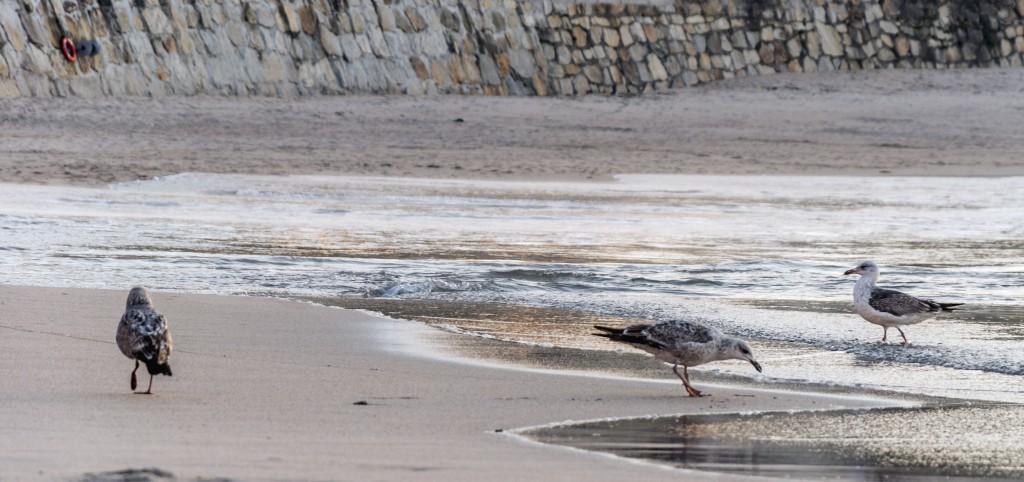In one or two sentences, can you explain what this image depicts? In this image we can see three birds, among them two birds are on the ground and one is in the water, in the background we can see the wall. 